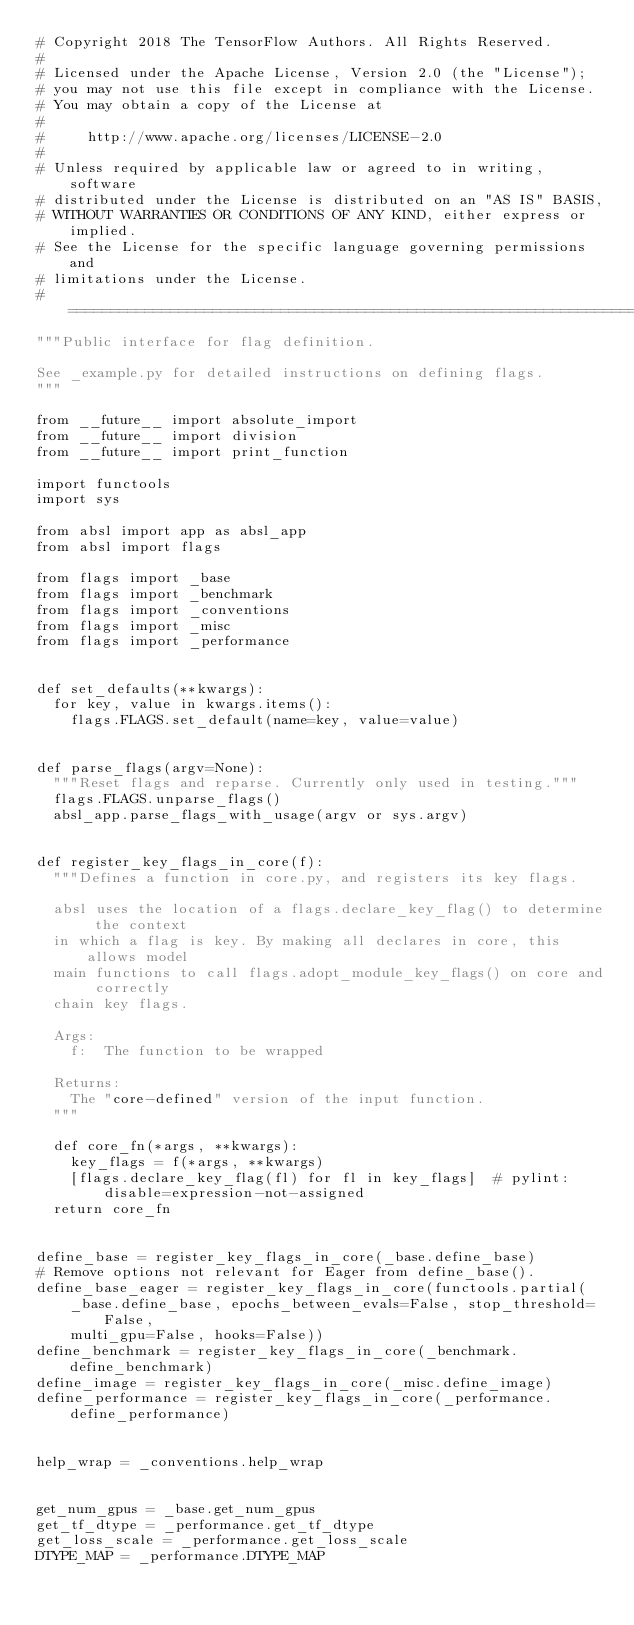Convert code to text. <code><loc_0><loc_0><loc_500><loc_500><_Python_># Copyright 2018 The TensorFlow Authors. All Rights Reserved.
#
# Licensed under the Apache License, Version 2.0 (the "License");
# you may not use this file except in compliance with the License.
# You may obtain a copy of the License at
#
#     http://www.apache.org/licenses/LICENSE-2.0
#
# Unless required by applicable law or agreed to in writing, software
# distributed under the License is distributed on an "AS IS" BASIS,
# WITHOUT WARRANTIES OR CONDITIONS OF ANY KIND, either express or implied.
# See the License for the specific language governing permissions and
# limitations under the License.
# ==============================================================================
"""Public interface for flag definition.

See _example.py for detailed instructions on defining flags.
"""

from __future__ import absolute_import
from __future__ import division
from __future__ import print_function

import functools
import sys

from absl import app as absl_app
from absl import flags

from flags import _base
from flags import _benchmark
from flags import _conventions
from flags import _misc
from flags import _performance


def set_defaults(**kwargs):
  for key, value in kwargs.items():
    flags.FLAGS.set_default(name=key, value=value)


def parse_flags(argv=None):
  """Reset flags and reparse. Currently only used in testing."""
  flags.FLAGS.unparse_flags()
  absl_app.parse_flags_with_usage(argv or sys.argv)


def register_key_flags_in_core(f):
  """Defines a function in core.py, and registers its key flags.

  absl uses the location of a flags.declare_key_flag() to determine the context
  in which a flag is key. By making all declares in core, this allows model
  main functions to call flags.adopt_module_key_flags() on core and correctly
  chain key flags.

  Args:
    f:  The function to be wrapped

  Returns:
    The "core-defined" version of the input function.
  """

  def core_fn(*args, **kwargs):
    key_flags = f(*args, **kwargs)
    [flags.declare_key_flag(fl) for fl in key_flags]  # pylint: disable=expression-not-assigned
  return core_fn


define_base = register_key_flags_in_core(_base.define_base)
# Remove options not relevant for Eager from define_base().
define_base_eager = register_key_flags_in_core(functools.partial(
    _base.define_base, epochs_between_evals=False, stop_threshold=False,
    multi_gpu=False, hooks=False))
define_benchmark = register_key_flags_in_core(_benchmark.define_benchmark)
define_image = register_key_flags_in_core(_misc.define_image)
define_performance = register_key_flags_in_core(_performance.define_performance)


help_wrap = _conventions.help_wrap


get_num_gpus = _base.get_num_gpus
get_tf_dtype = _performance.get_tf_dtype
get_loss_scale = _performance.get_loss_scale
DTYPE_MAP = _performance.DTYPE_MAP
</code> 